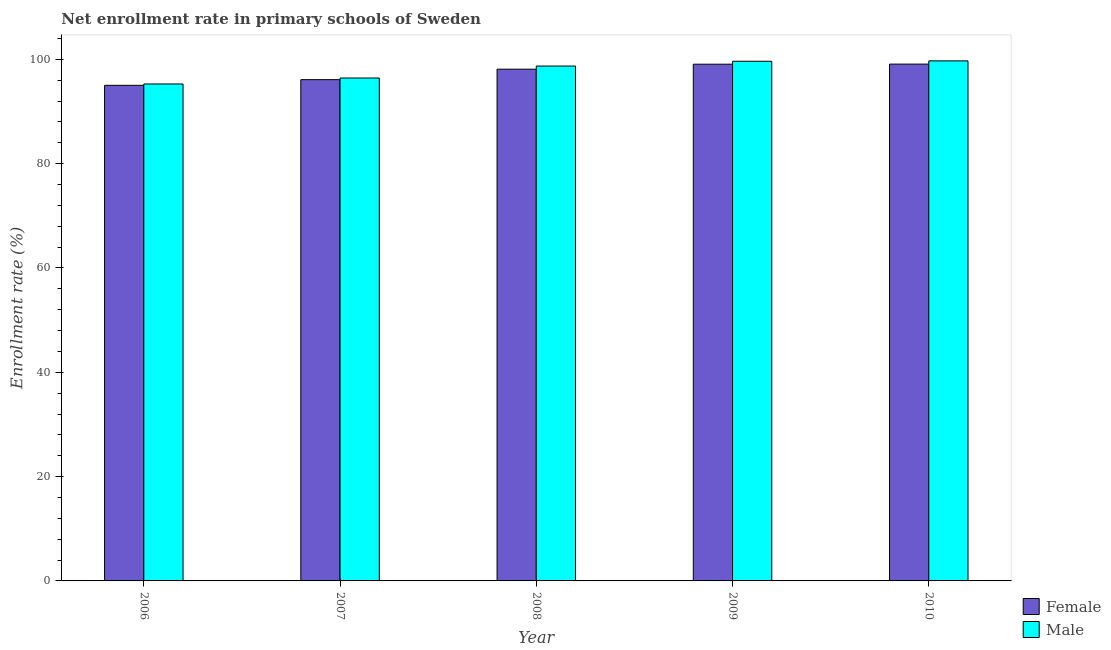How many different coloured bars are there?
Your answer should be compact. 2. How many bars are there on the 5th tick from the right?
Offer a terse response. 2. What is the enrollment rate of female students in 2010?
Provide a succinct answer. 99.08. Across all years, what is the maximum enrollment rate of female students?
Offer a very short reply. 99.08. Across all years, what is the minimum enrollment rate of female students?
Keep it short and to the point. 95.01. In which year was the enrollment rate of male students maximum?
Give a very brief answer. 2010. What is the total enrollment rate of female students in the graph?
Ensure brevity in your answer.  487.35. What is the difference between the enrollment rate of male students in 2007 and that in 2010?
Give a very brief answer. -3.29. What is the difference between the enrollment rate of male students in 2008 and the enrollment rate of female students in 2006?
Offer a very short reply. 3.44. What is the average enrollment rate of female students per year?
Offer a terse response. 97.47. What is the ratio of the enrollment rate of female students in 2007 to that in 2009?
Offer a terse response. 0.97. Is the difference between the enrollment rate of male students in 2008 and 2010 greater than the difference between the enrollment rate of female students in 2008 and 2010?
Offer a terse response. No. What is the difference between the highest and the second highest enrollment rate of female students?
Offer a terse response. 0.02. What is the difference between the highest and the lowest enrollment rate of male students?
Provide a succinct answer. 4.43. In how many years, is the enrollment rate of female students greater than the average enrollment rate of female students taken over all years?
Give a very brief answer. 3. How many bars are there?
Ensure brevity in your answer.  10. Does the graph contain any zero values?
Give a very brief answer. No. Does the graph contain grids?
Give a very brief answer. No. What is the title of the graph?
Ensure brevity in your answer.  Net enrollment rate in primary schools of Sweden. Does "Primary" appear as one of the legend labels in the graph?
Your answer should be very brief. No. What is the label or title of the Y-axis?
Offer a terse response. Enrollment rate (%). What is the Enrollment rate (%) of Female in 2006?
Ensure brevity in your answer.  95.01. What is the Enrollment rate (%) in Male in 2006?
Offer a very short reply. 95.27. What is the Enrollment rate (%) in Female in 2007?
Your answer should be compact. 96.1. What is the Enrollment rate (%) in Male in 2007?
Provide a short and direct response. 96.41. What is the Enrollment rate (%) of Female in 2008?
Make the answer very short. 98.1. What is the Enrollment rate (%) of Male in 2008?
Provide a short and direct response. 98.71. What is the Enrollment rate (%) of Female in 2009?
Ensure brevity in your answer.  99.06. What is the Enrollment rate (%) of Male in 2009?
Give a very brief answer. 99.63. What is the Enrollment rate (%) of Female in 2010?
Provide a succinct answer. 99.08. What is the Enrollment rate (%) in Male in 2010?
Your answer should be very brief. 99.7. Across all years, what is the maximum Enrollment rate (%) in Female?
Your answer should be compact. 99.08. Across all years, what is the maximum Enrollment rate (%) in Male?
Offer a terse response. 99.7. Across all years, what is the minimum Enrollment rate (%) in Female?
Ensure brevity in your answer.  95.01. Across all years, what is the minimum Enrollment rate (%) in Male?
Give a very brief answer. 95.27. What is the total Enrollment rate (%) in Female in the graph?
Offer a terse response. 487.35. What is the total Enrollment rate (%) in Male in the graph?
Offer a terse response. 489.71. What is the difference between the Enrollment rate (%) in Female in 2006 and that in 2007?
Provide a succinct answer. -1.09. What is the difference between the Enrollment rate (%) in Male in 2006 and that in 2007?
Make the answer very short. -1.14. What is the difference between the Enrollment rate (%) of Female in 2006 and that in 2008?
Provide a succinct answer. -3.09. What is the difference between the Enrollment rate (%) of Male in 2006 and that in 2008?
Provide a succinct answer. -3.44. What is the difference between the Enrollment rate (%) in Female in 2006 and that in 2009?
Your response must be concise. -4.05. What is the difference between the Enrollment rate (%) of Male in 2006 and that in 2009?
Your answer should be very brief. -4.36. What is the difference between the Enrollment rate (%) of Female in 2006 and that in 2010?
Make the answer very short. -4.07. What is the difference between the Enrollment rate (%) of Male in 2006 and that in 2010?
Make the answer very short. -4.43. What is the difference between the Enrollment rate (%) of Female in 2007 and that in 2008?
Your response must be concise. -2.01. What is the difference between the Enrollment rate (%) in Male in 2007 and that in 2008?
Keep it short and to the point. -2.3. What is the difference between the Enrollment rate (%) in Female in 2007 and that in 2009?
Your answer should be very brief. -2.96. What is the difference between the Enrollment rate (%) of Male in 2007 and that in 2009?
Your answer should be compact. -3.21. What is the difference between the Enrollment rate (%) of Female in 2007 and that in 2010?
Provide a succinct answer. -2.98. What is the difference between the Enrollment rate (%) of Male in 2007 and that in 2010?
Provide a short and direct response. -3.29. What is the difference between the Enrollment rate (%) of Female in 2008 and that in 2009?
Provide a succinct answer. -0.95. What is the difference between the Enrollment rate (%) in Male in 2008 and that in 2009?
Ensure brevity in your answer.  -0.92. What is the difference between the Enrollment rate (%) of Female in 2008 and that in 2010?
Keep it short and to the point. -0.97. What is the difference between the Enrollment rate (%) of Male in 2008 and that in 2010?
Ensure brevity in your answer.  -0.99. What is the difference between the Enrollment rate (%) of Female in 2009 and that in 2010?
Your answer should be compact. -0.02. What is the difference between the Enrollment rate (%) of Male in 2009 and that in 2010?
Make the answer very short. -0.07. What is the difference between the Enrollment rate (%) of Female in 2006 and the Enrollment rate (%) of Male in 2007?
Your answer should be compact. -1.4. What is the difference between the Enrollment rate (%) of Female in 2006 and the Enrollment rate (%) of Male in 2008?
Offer a very short reply. -3.7. What is the difference between the Enrollment rate (%) of Female in 2006 and the Enrollment rate (%) of Male in 2009?
Ensure brevity in your answer.  -4.61. What is the difference between the Enrollment rate (%) of Female in 2006 and the Enrollment rate (%) of Male in 2010?
Provide a short and direct response. -4.69. What is the difference between the Enrollment rate (%) of Female in 2007 and the Enrollment rate (%) of Male in 2008?
Your answer should be compact. -2.61. What is the difference between the Enrollment rate (%) of Female in 2007 and the Enrollment rate (%) of Male in 2009?
Your answer should be compact. -3.53. What is the difference between the Enrollment rate (%) of Female in 2007 and the Enrollment rate (%) of Male in 2010?
Your response must be concise. -3.6. What is the difference between the Enrollment rate (%) in Female in 2008 and the Enrollment rate (%) in Male in 2009?
Offer a very short reply. -1.52. What is the difference between the Enrollment rate (%) in Female in 2008 and the Enrollment rate (%) in Male in 2010?
Provide a succinct answer. -1.59. What is the difference between the Enrollment rate (%) of Female in 2009 and the Enrollment rate (%) of Male in 2010?
Make the answer very short. -0.64. What is the average Enrollment rate (%) in Female per year?
Ensure brevity in your answer.  97.47. What is the average Enrollment rate (%) in Male per year?
Give a very brief answer. 97.94. In the year 2006, what is the difference between the Enrollment rate (%) of Female and Enrollment rate (%) of Male?
Keep it short and to the point. -0.26. In the year 2007, what is the difference between the Enrollment rate (%) of Female and Enrollment rate (%) of Male?
Provide a short and direct response. -0.31. In the year 2008, what is the difference between the Enrollment rate (%) of Female and Enrollment rate (%) of Male?
Your answer should be very brief. -0.6. In the year 2009, what is the difference between the Enrollment rate (%) in Female and Enrollment rate (%) in Male?
Offer a terse response. -0.57. In the year 2010, what is the difference between the Enrollment rate (%) of Female and Enrollment rate (%) of Male?
Give a very brief answer. -0.62. What is the ratio of the Enrollment rate (%) of Female in 2006 to that in 2007?
Your answer should be very brief. 0.99. What is the ratio of the Enrollment rate (%) in Female in 2006 to that in 2008?
Keep it short and to the point. 0.97. What is the ratio of the Enrollment rate (%) of Male in 2006 to that in 2008?
Keep it short and to the point. 0.97. What is the ratio of the Enrollment rate (%) of Female in 2006 to that in 2009?
Ensure brevity in your answer.  0.96. What is the ratio of the Enrollment rate (%) of Male in 2006 to that in 2009?
Make the answer very short. 0.96. What is the ratio of the Enrollment rate (%) of Female in 2006 to that in 2010?
Make the answer very short. 0.96. What is the ratio of the Enrollment rate (%) of Male in 2006 to that in 2010?
Provide a succinct answer. 0.96. What is the ratio of the Enrollment rate (%) of Female in 2007 to that in 2008?
Offer a very short reply. 0.98. What is the ratio of the Enrollment rate (%) of Male in 2007 to that in 2008?
Provide a succinct answer. 0.98. What is the ratio of the Enrollment rate (%) in Female in 2007 to that in 2009?
Provide a short and direct response. 0.97. What is the ratio of the Enrollment rate (%) of Female in 2007 to that in 2010?
Offer a very short reply. 0.97. What is the ratio of the Enrollment rate (%) of Male in 2007 to that in 2010?
Your answer should be very brief. 0.97. What is the ratio of the Enrollment rate (%) in Female in 2008 to that in 2010?
Give a very brief answer. 0.99. What is the ratio of the Enrollment rate (%) of Female in 2009 to that in 2010?
Give a very brief answer. 1. What is the difference between the highest and the second highest Enrollment rate (%) in Female?
Provide a succinct answer. 0.02. What is the difference between the highest and the second highest Enrollment rate (%) in Male?
Your response must be concise. 0.07. What is the difference between the highest and the lowest Enrollment rate (%) in Female?
Ensure brevity in your answer.  4.07. What is the difference between the highest and the lowest Enrollment rate (%) in Male?
Your answer should be very brief. 4.43. 